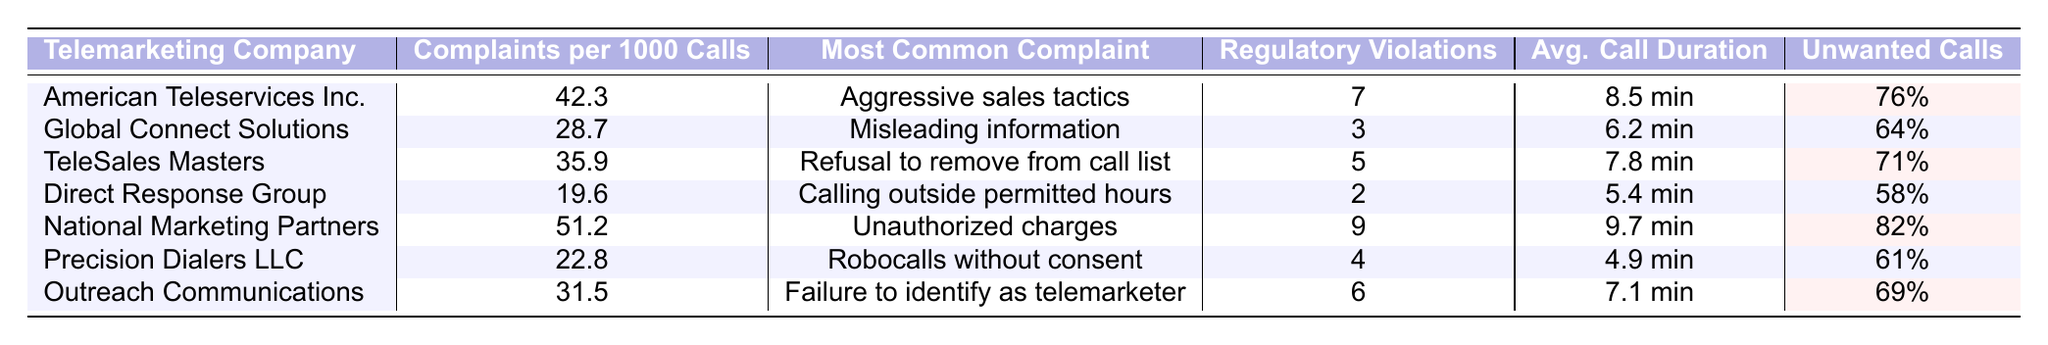What is the telemarketing company with the highest complaints per 1000 calls? By reviewing the table, I can identify that National Marketing Partners has the highest complaints per 1000 calls at 51.2.
Answer: National Marketing Partners Which company has the most common complaint about unauthorized charges? I locate the row for National Marketing Partners, where the most common complaint is listed as unauthorized charges.
Answer: National Marketing Partners What is the average call duration for TeleSales Masters? The table shows that the average call duration for TeleSales Masters is 7.8 minutes.
Answer: 7.8 minutes How many regulatory violations does American Teleservices Inc. have? Within the table, I see that American Teleservices Inc. has 7 regulatory violations.
Answer: 7 What percentage of unwanted calls does Precision Dialers LLC have compared to Global Connect Solutions? Precision Dialers LLC has 61% unwanted calls, while Global Connect Solutions has 64%. The difference is 64% - 61% = 3%.
Answer: 3% Which company has the lowest complaints per 1000 calls and what is that rate? I can see that Direct Response Group has the lowest complaints per 1000 calls at a rate of 19.6.
Answer: 19.6 Is it true that all companies have a percentage of unwanted calls over 50%? By analyzing the table, I find that all companies listed have unwanted call percentages above 50%.
Answer: Yes What is the average complaints per 1000 calls for companies with regulatory violations greater than 5? The companies with more than 5 regulatory violations are American Teleservices Inc. (7), TeleSales Masters (5), and National Marketing Partners (9). Their complaints per 1000 calls are 42.3, 35.9, and 51.2 respectively. The average is (42.3 + 35.9 + 51.2) / 3 = 43.13.
Answer: 43.13 Which company has the least percentage of unwanted calls, and what is that percentage? By examining the table, I find that Direct Response Group has the least percentage of unwanted calls at 58%.
Answer: 58% How many companies have aggressive sales tactics as their most common complaint? The table indicates that only one company, American Teleservices Inc., lists aggressive sales tactics as their most common complaint.
Answer: 1 